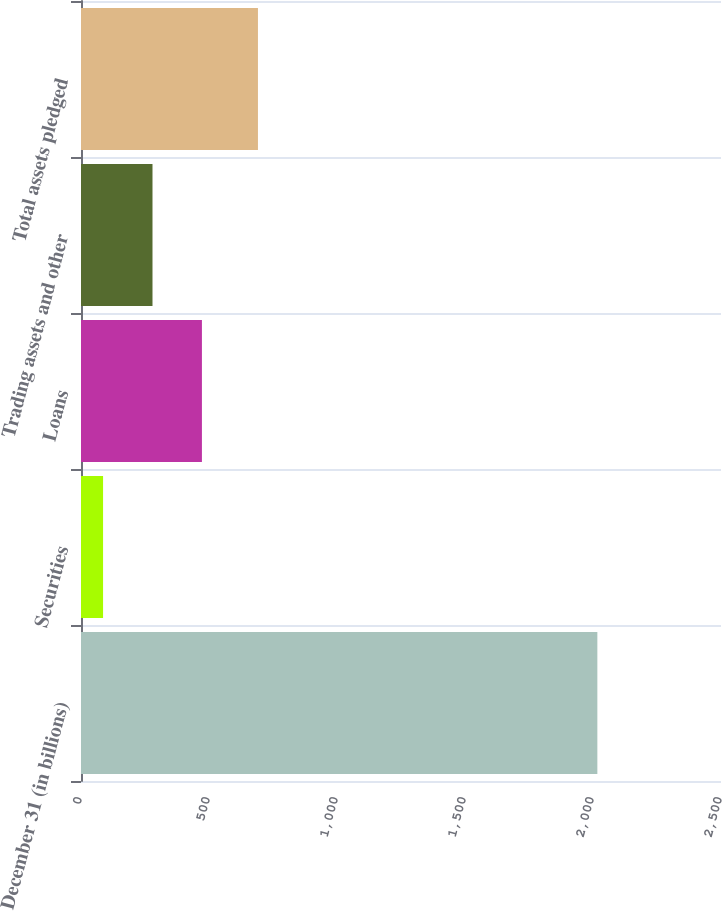Convert chart. <chart><loc_0><loc_0><loc_500><loc_500><bar_chart><fcel>December 31 (in billions)<fcel>Securities<fcel>Loans<fcel>Trading assets and other<fcel>Total assets pledged<nl><fcel>2017<fcel>86.2<fcel>472.36<fcel>279.28<fcel>691.2<nl></chart> 